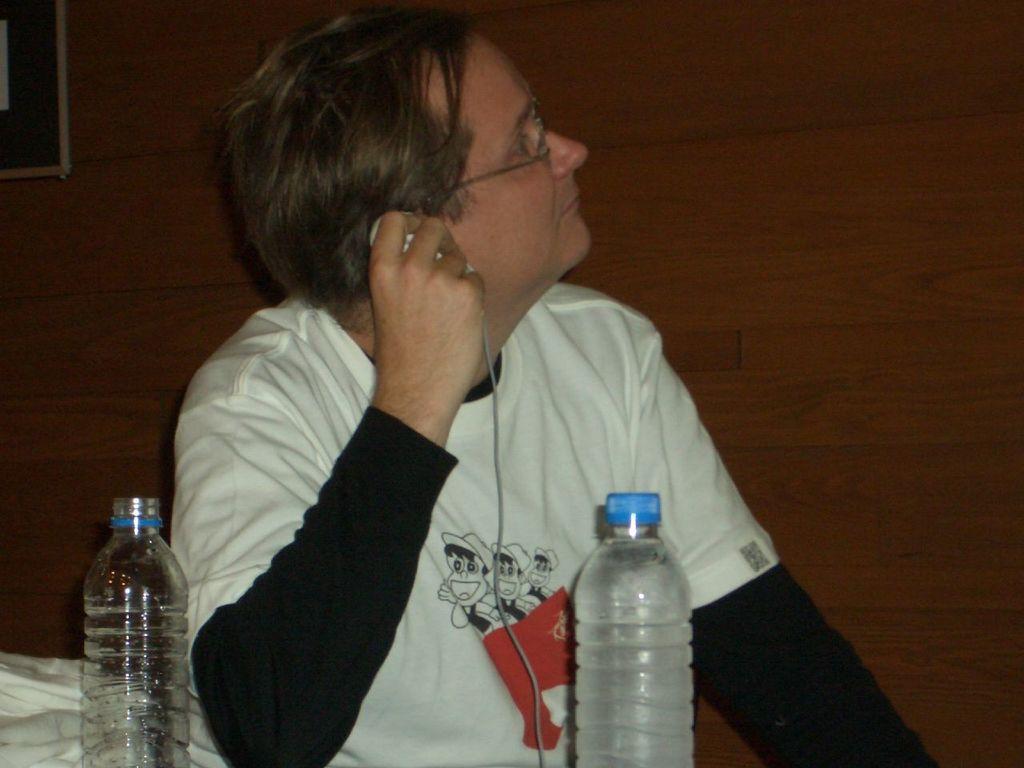How would you summarize this image in a sentence or two? Here we can see a person sitting in front of a table and there are couple of bottles placed on the table and this person is hearing something with the help of headphones 